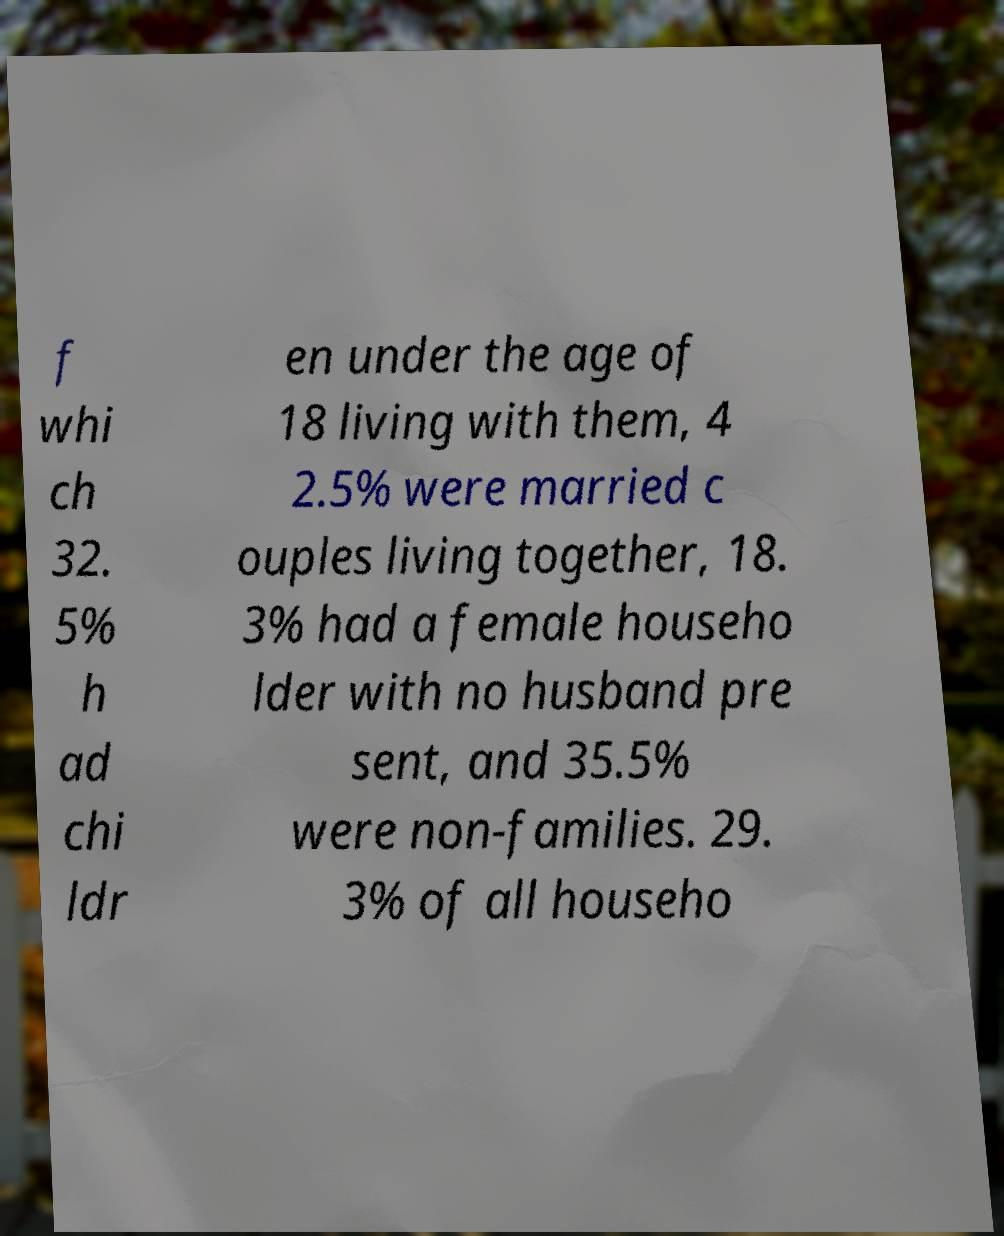There's text embedded in this image that I need extracted. Can you transcribe it verbatim? f whi ch 32. 5% h ad chi ldr en under the age of 18 living with them, 4 2.5% were married c ouples living together, 18. 3% had a female househo lder with no husband pre sent, and 35.5% were non-families. 29. 3% of all househo 